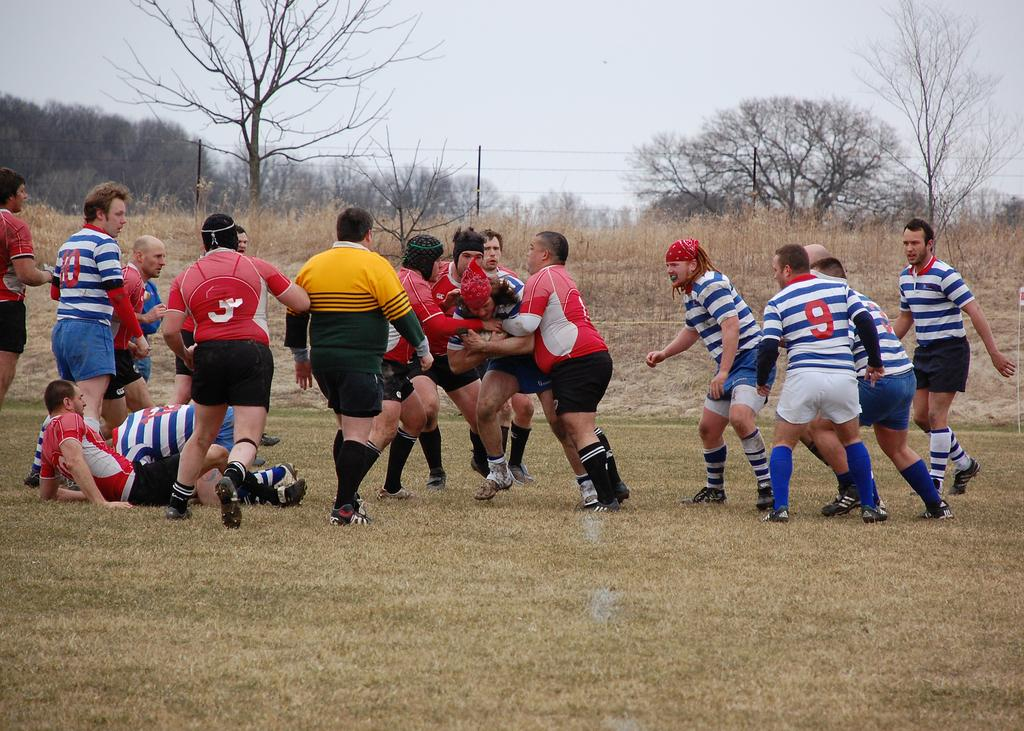What is happening on the ground in the image? There are people on the ground in the image. What can be seen in the background of the image? There are trees and a pole with wires in the background of the image. What is visible in the sky in the image? The sky is visible in the background of the image. What type of camera is being used to support the people in the image? There is no camera present in the image, and the people are not being supported by any device. What offer is being made by the trees in the background of the image? The trees in the background of the image are not making any offer; they are simply part of the natural scenery. 